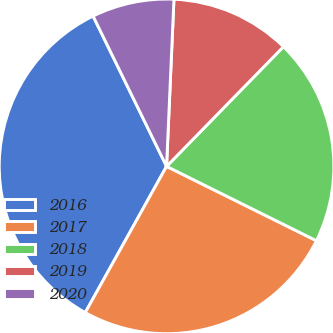Convert chart to OTSL. <chart><loc_0><loc_0><loc_500><loc_500><pie_chart><fcel>2016<fcel>2017<fcel>2018<fcel>2019<fcel>2020<nl><fcel>34.69%<fcel>25.75%<fcel>20.02%<fcel>11.61%<fcel>7.94%<nl></chart> 